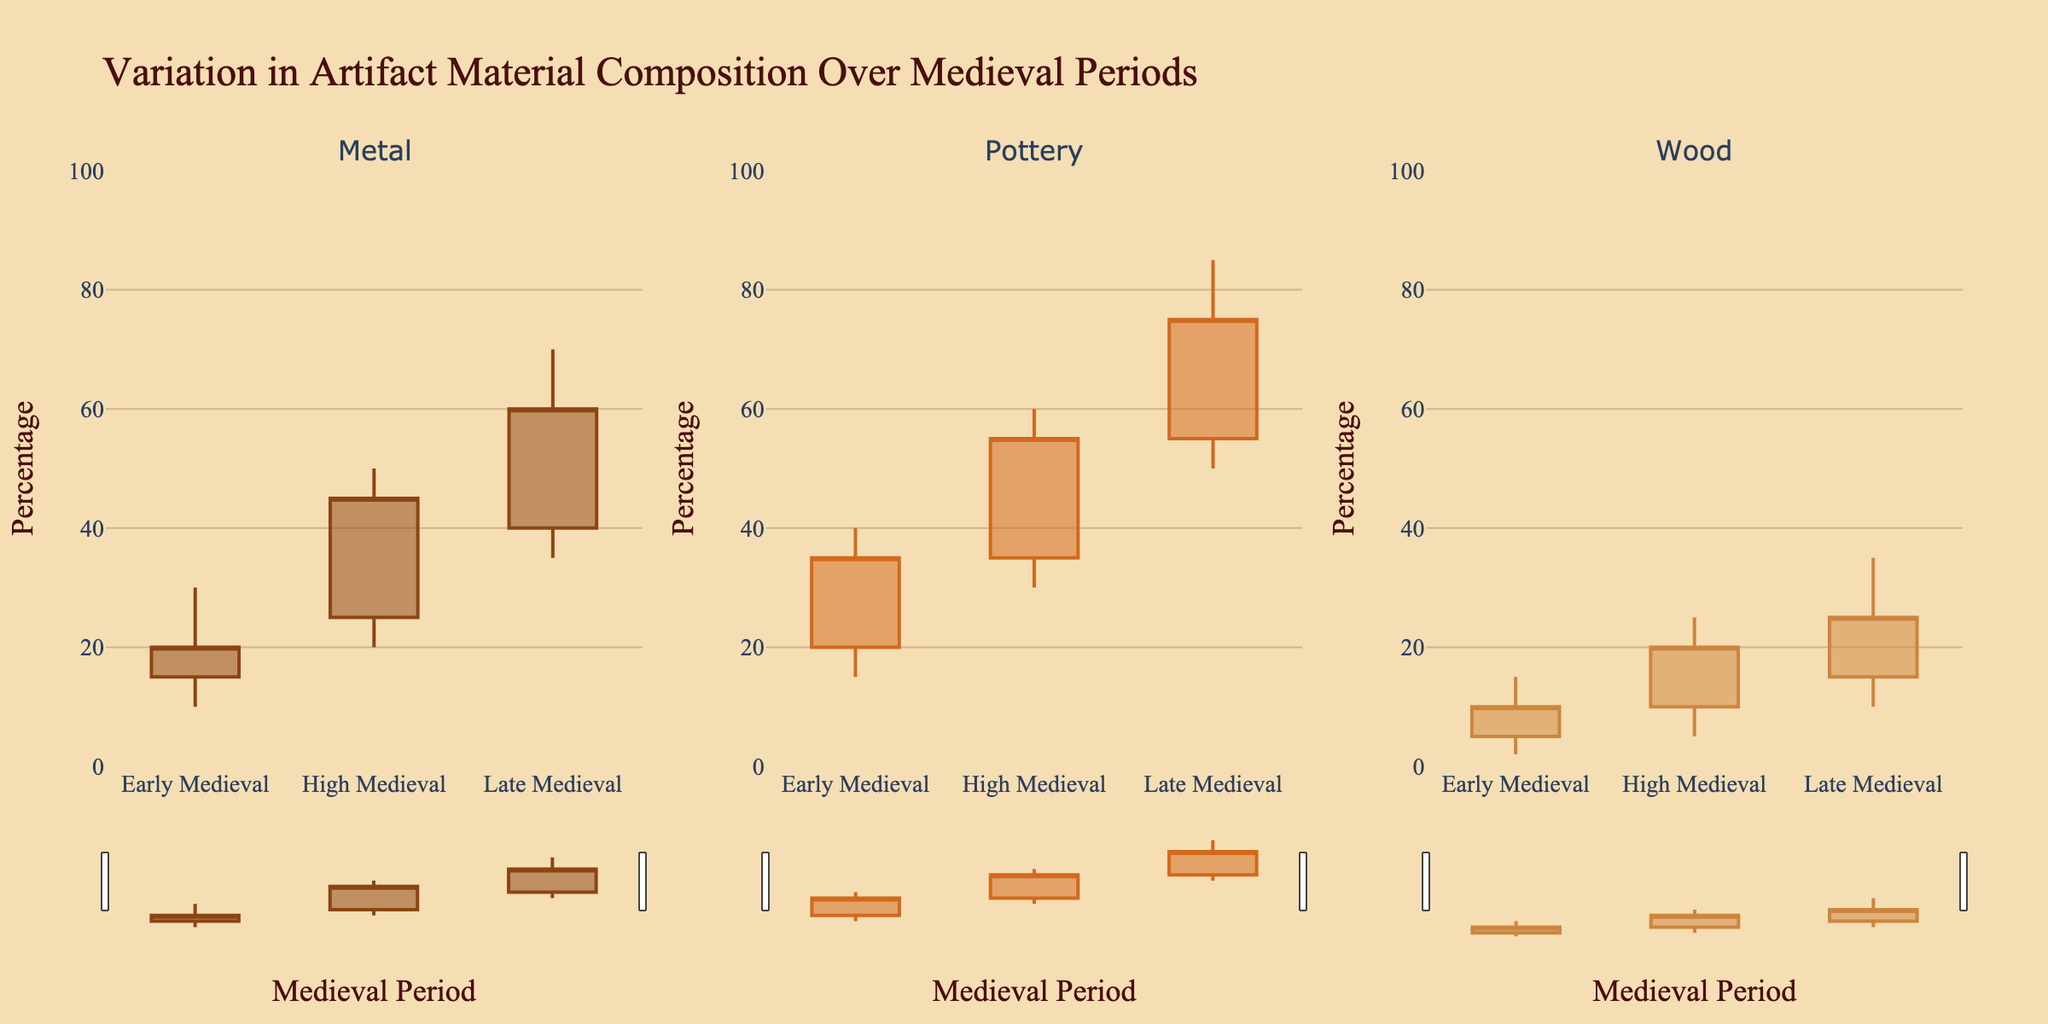What is the title of the figure? The title is usually found at the top of the figure and states the main purpose of the visual representation. In this case, it reads "Variation in Artifact Material Composition Over Medieval Periods".
Answer: Variation in Artifact Material Composition Over Medieval Periods Which axis represents the medieval periods, and which axis represents the percentage values? The x-axis typically represents the independent variable, in this case, the medieval periods. The y-axis represents the dependent variable, which is the percentage of material composition over time.
Answer: The x-axis represents the medieval periods, and the y-axis represents the percentage values How many subplots are there, and what does each subplot represent? Each subplot represents a different material type (Metal, Pottery, Wood). There are three subplots, each corresponding to one of these materials.
Answer: Three subplots for Metal, Pottery, and Wood What is the approximate percentage range for Pottery in the Late Medieval period? For Pottery in the Late Medieval period, look at the candlestick that corresponds to this period and material. The low is at 50%, the high is at 85%, the open is at 55%, and the close is at 75%. Therefore, the percentage range is from 50% to 85%.
Answer: 50% to 85% Which material shows the greatest maximum percentage in the High Medieval period? Examine the high value for each material in the High Medieval period. Metal reaches 50%, Pottery reaches 60%, and Wood reaches 25%. So, Pottery has the highest maximum percentage.
Answer: Pottery Did the percentage of Wood composition increase or decrease from the Early Medieval to the Late Medieval period? Compare the close values for Wood. In the Early Medieval period, it closes at 10%, and in the Late Medieval period, it closes at 25%. This shows an increase in Wood composition.
Answer: Increase What is the median opening value for Metal across all periods? The opening values for Metal are 15, 25, and 40. To find the median, list the values in order: 15, 25, 40. Since there are three values, the median is the middle value, which is 25.
Answer: 25 